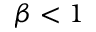Convert formula to latex. <formula><loc_0><loc_0><loc_500><loc_500>\beta < 1</formula> 